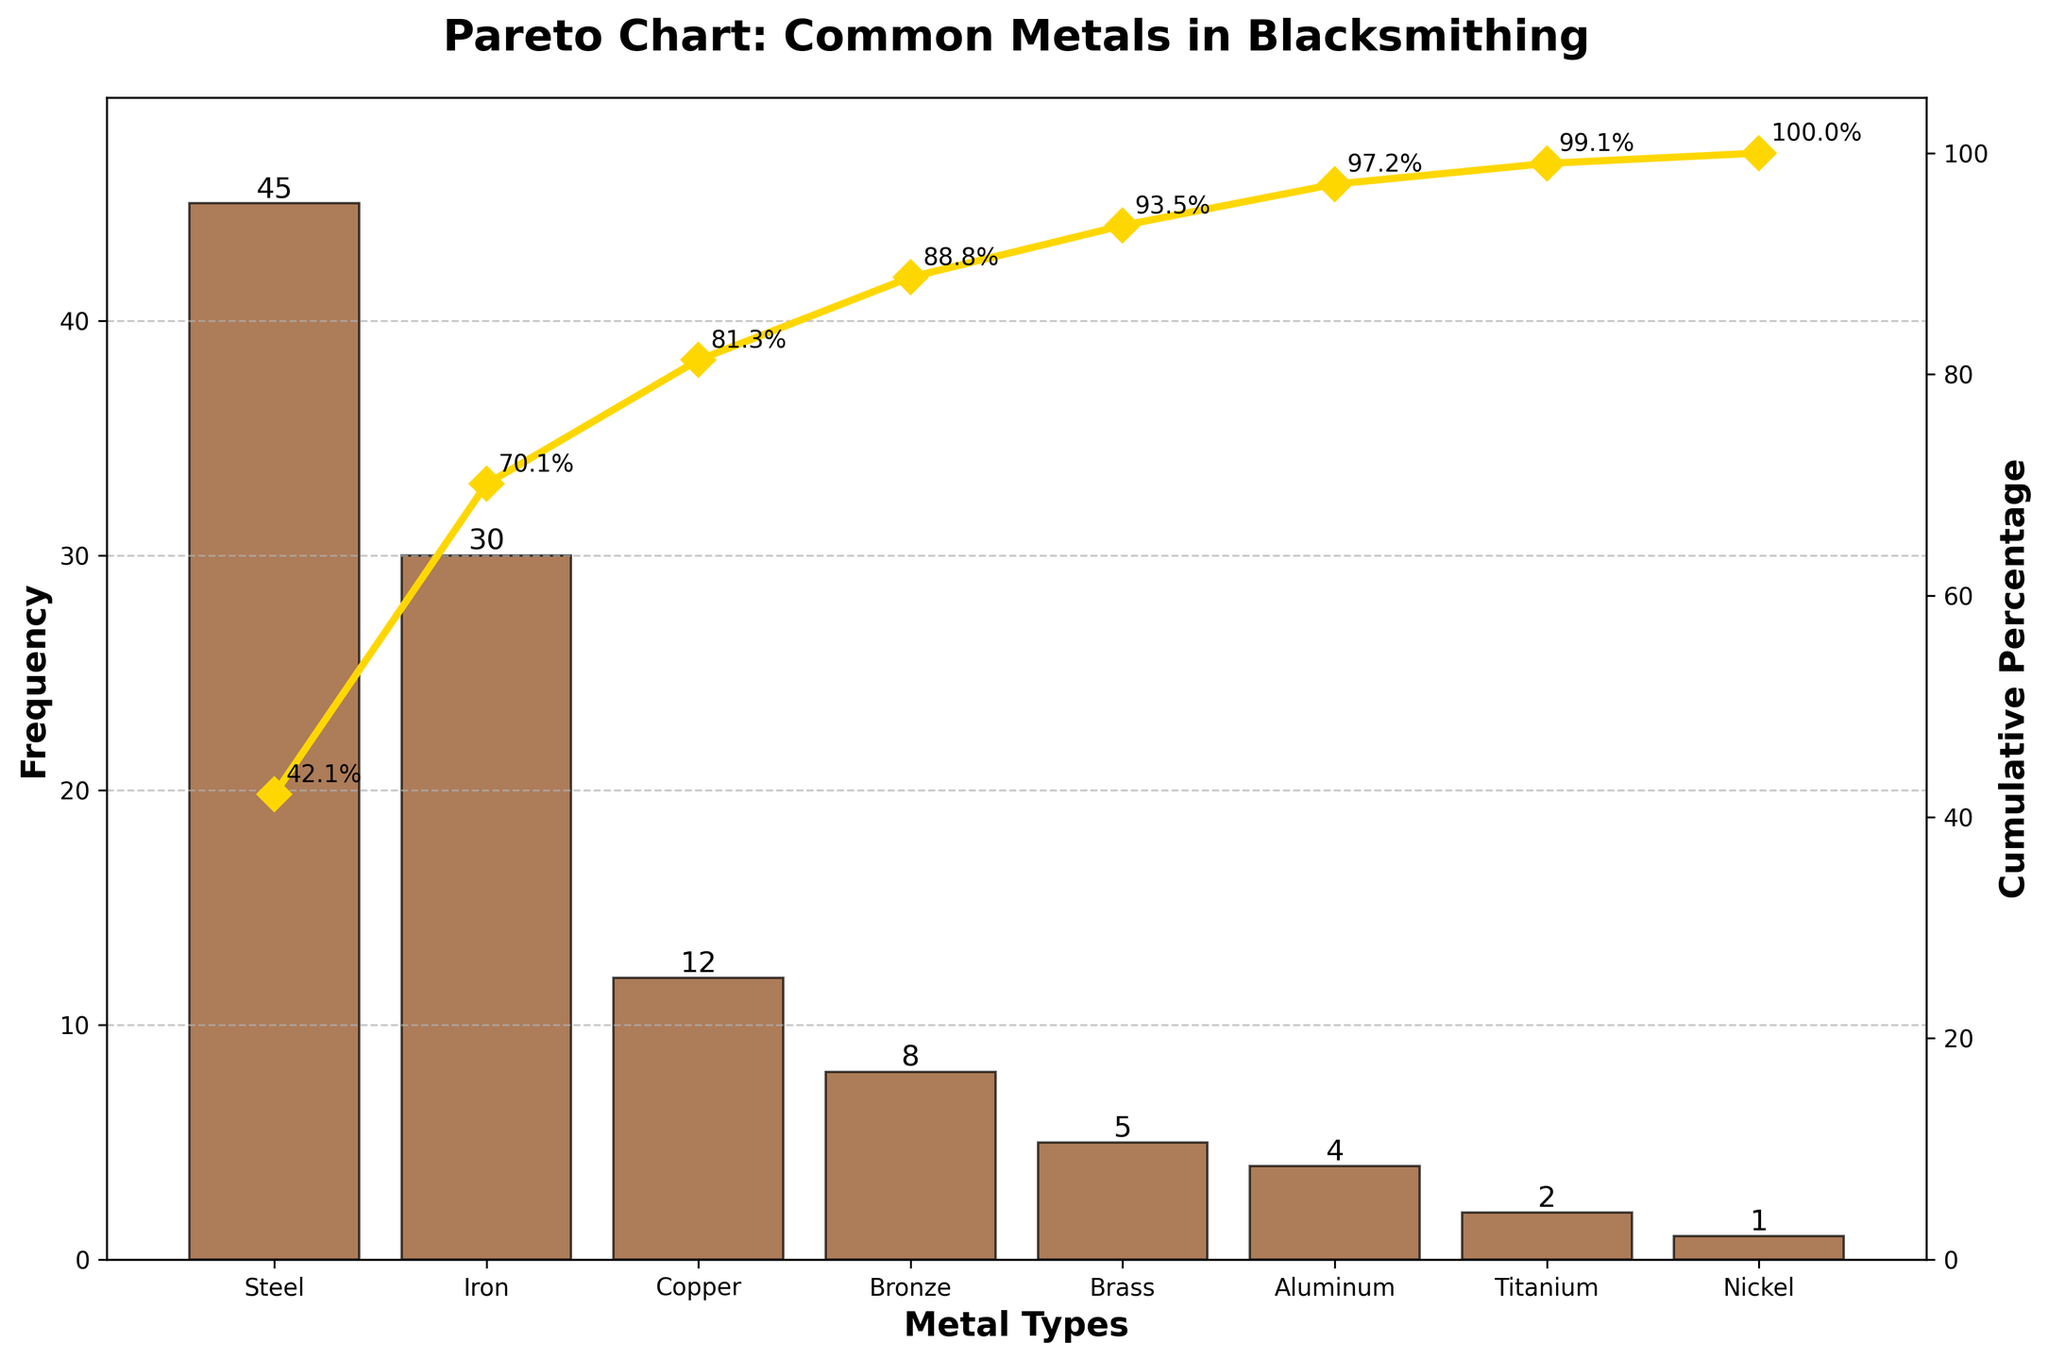what is the most frequently used metal in blacksmithing projects according to the chart? The bar for Steel is the tallest among all the bars in the chart, indicating that it has the highest frequency.
Answer: Steel which metal has the lowest frequency of use in blacksmithing projects? The bar for Nickel is the shortest among all the bars in the chart, indicating that it has the lowest frequency.
Answer: Nickel how many metal types are represented in the chart? Count the number of bars or x-axis labels in the chart which represent different metal types.
Answer: 8 metals what is the cumulative percentage of Steel and Iron combined? The cumulative percentage for Steel is about 45%, and for Iron is about 74%. Adding these two percentages together gives 74%.
Answer: 74% which metal has a greater frequency of use, Copper or Brass? The bar for Copper is taller than the bar for Brass, which means Copper has a greater frequency of use.
Answer: Copper how much more frequently is Bronze used compared to Aluminum? The bar for Bronze shows a frequency of 8, while the bar for Aluminum shows a frequency of 4. Subtracting 4 from 8 gives the difference in frequency.
Answer: 4 what percentage of total use does Iron represent? The cumulative percentage for Iron is shown as around 74%, excluding the prior cumulative percentage of Steel which is 45%, the percentage of total use that Iron represents is around 30%.
Answer: 30% if you were to use half the total times Steel is used, what would this frequency be? The frequency for Steel is 45. Half of this value would be 45 / 2, which equals 22.5.
Answer: 22.5 how does the cumulative frequency change from Aluminum to Titanium? The cumulative frequency percentage for Aluminum is around 97%, and for Titanium, it's about 99%. The change is around 2%.
Answer: 2% which metal completes the 90% cumulative percentage when added after Copper? The cumulative percentage after Copper is about 80%. Adding the next metal, Bronze (8%), the cumulative percentage reaches 88%, close to 90%. When you include Brass, it goes beyond 90%. Therefore, it is Brass.
Answer: Brass 